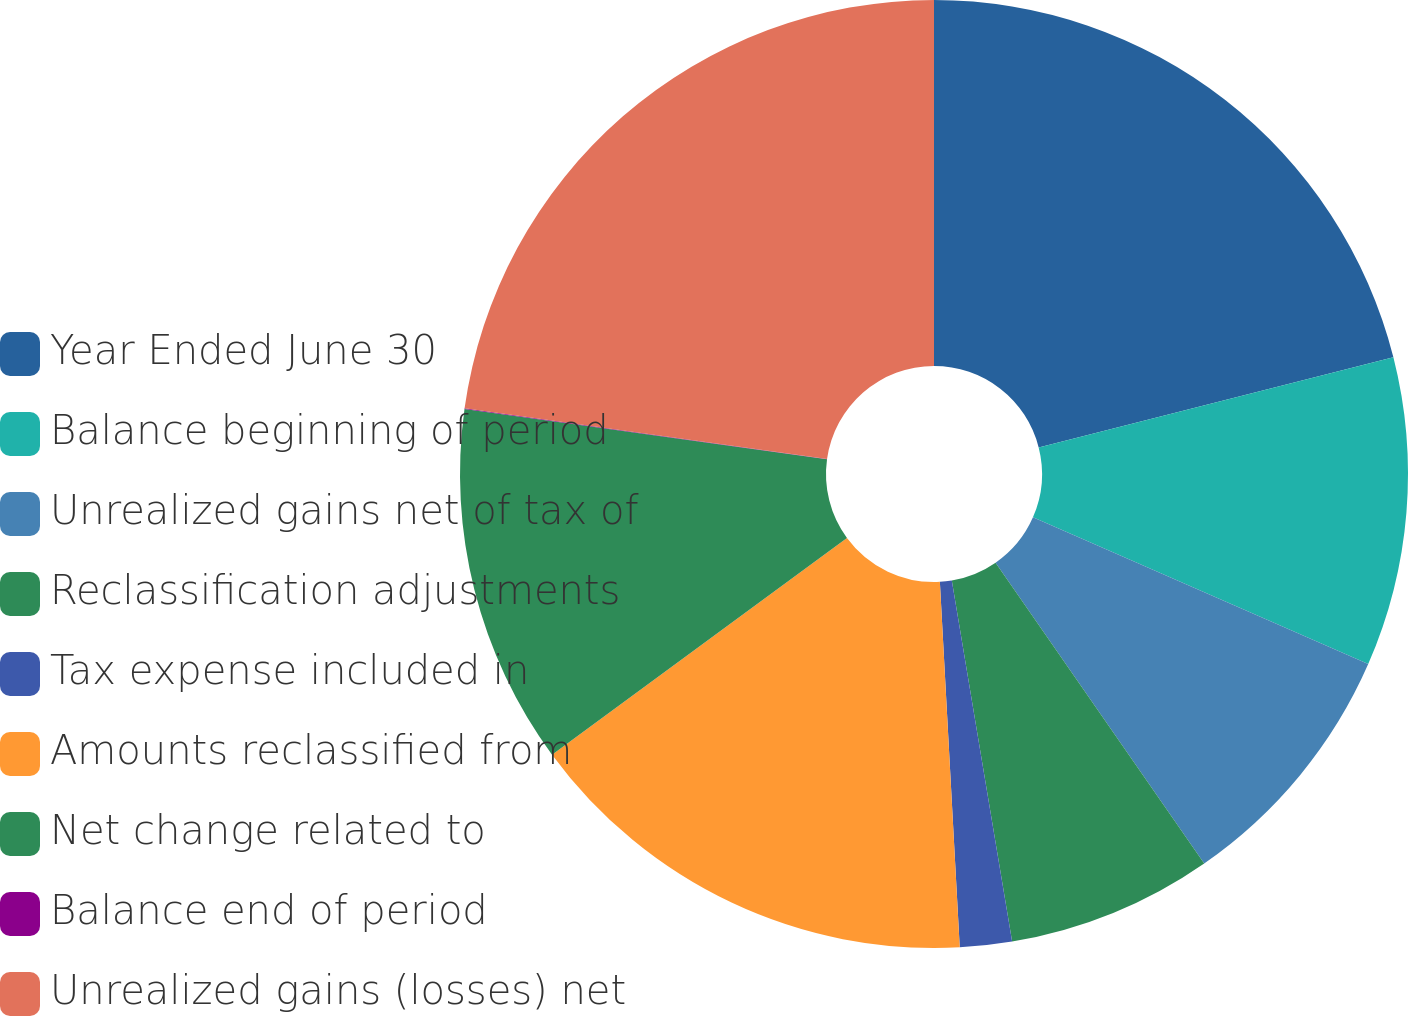<chart> <loc_0><loc_0><loc_500><loc_500><pie_chart><fcel>Year Ended June 30<fcel>Balance beginning of period<fcel>Unrealized gains net of tax of<fcel>Reclassification adjustments<fcel>Tax expense included in<fcel>Amounts reclassified from<fcel>Net change related to<fcel>Balance end of period<fcel>Unrealized gains (losses) net<nl><fcel>21.04%<fcel>10.53%<fcel>8.78%<fcel>7.02%<fcel>1.77%<fcel>15.78%<fcel>12.28%<fcel>0.02%<fcel>22.79%<nl></chart> 